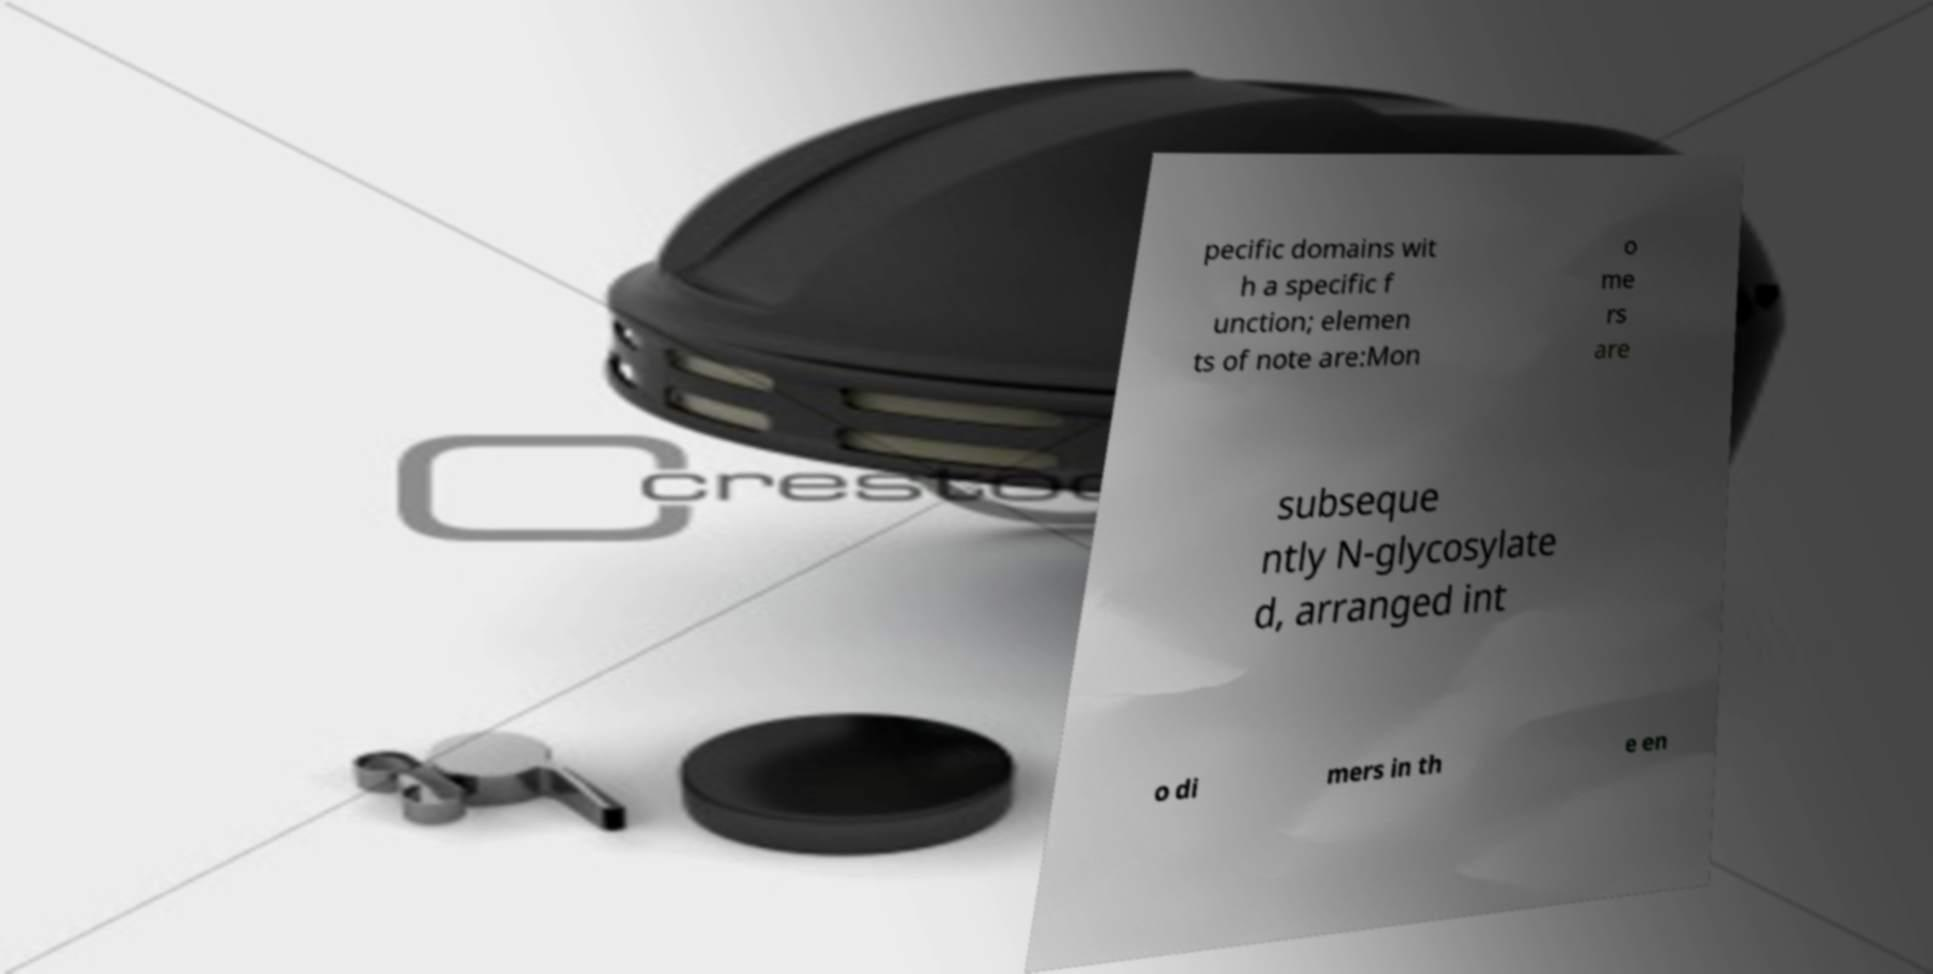There's text embedded in this image that I need extracted. Can you transcribe it verbatim? pecific domains wit h a specific f unction; elemen ts of note are:Mon o me rs are subseque ntly N-glycosylate d, arranged int o di mers in th e en 